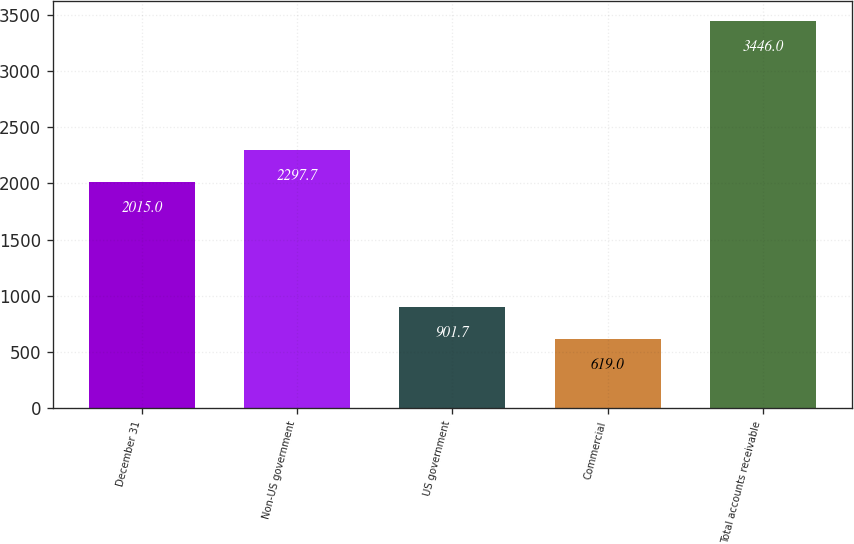Convert chart to OTSL. <chart><loc_0><loc_0><loc_500><loc_500><bar_chart><fcel>December 31<fcel>Non-US government<fcel>US government<fcel>Commercial<fcel>Total accounts receivable<nl><fcel>2015<fcel>2297.7<fcel>901.7<fcel>619<fcel>3446<nl></chart> 